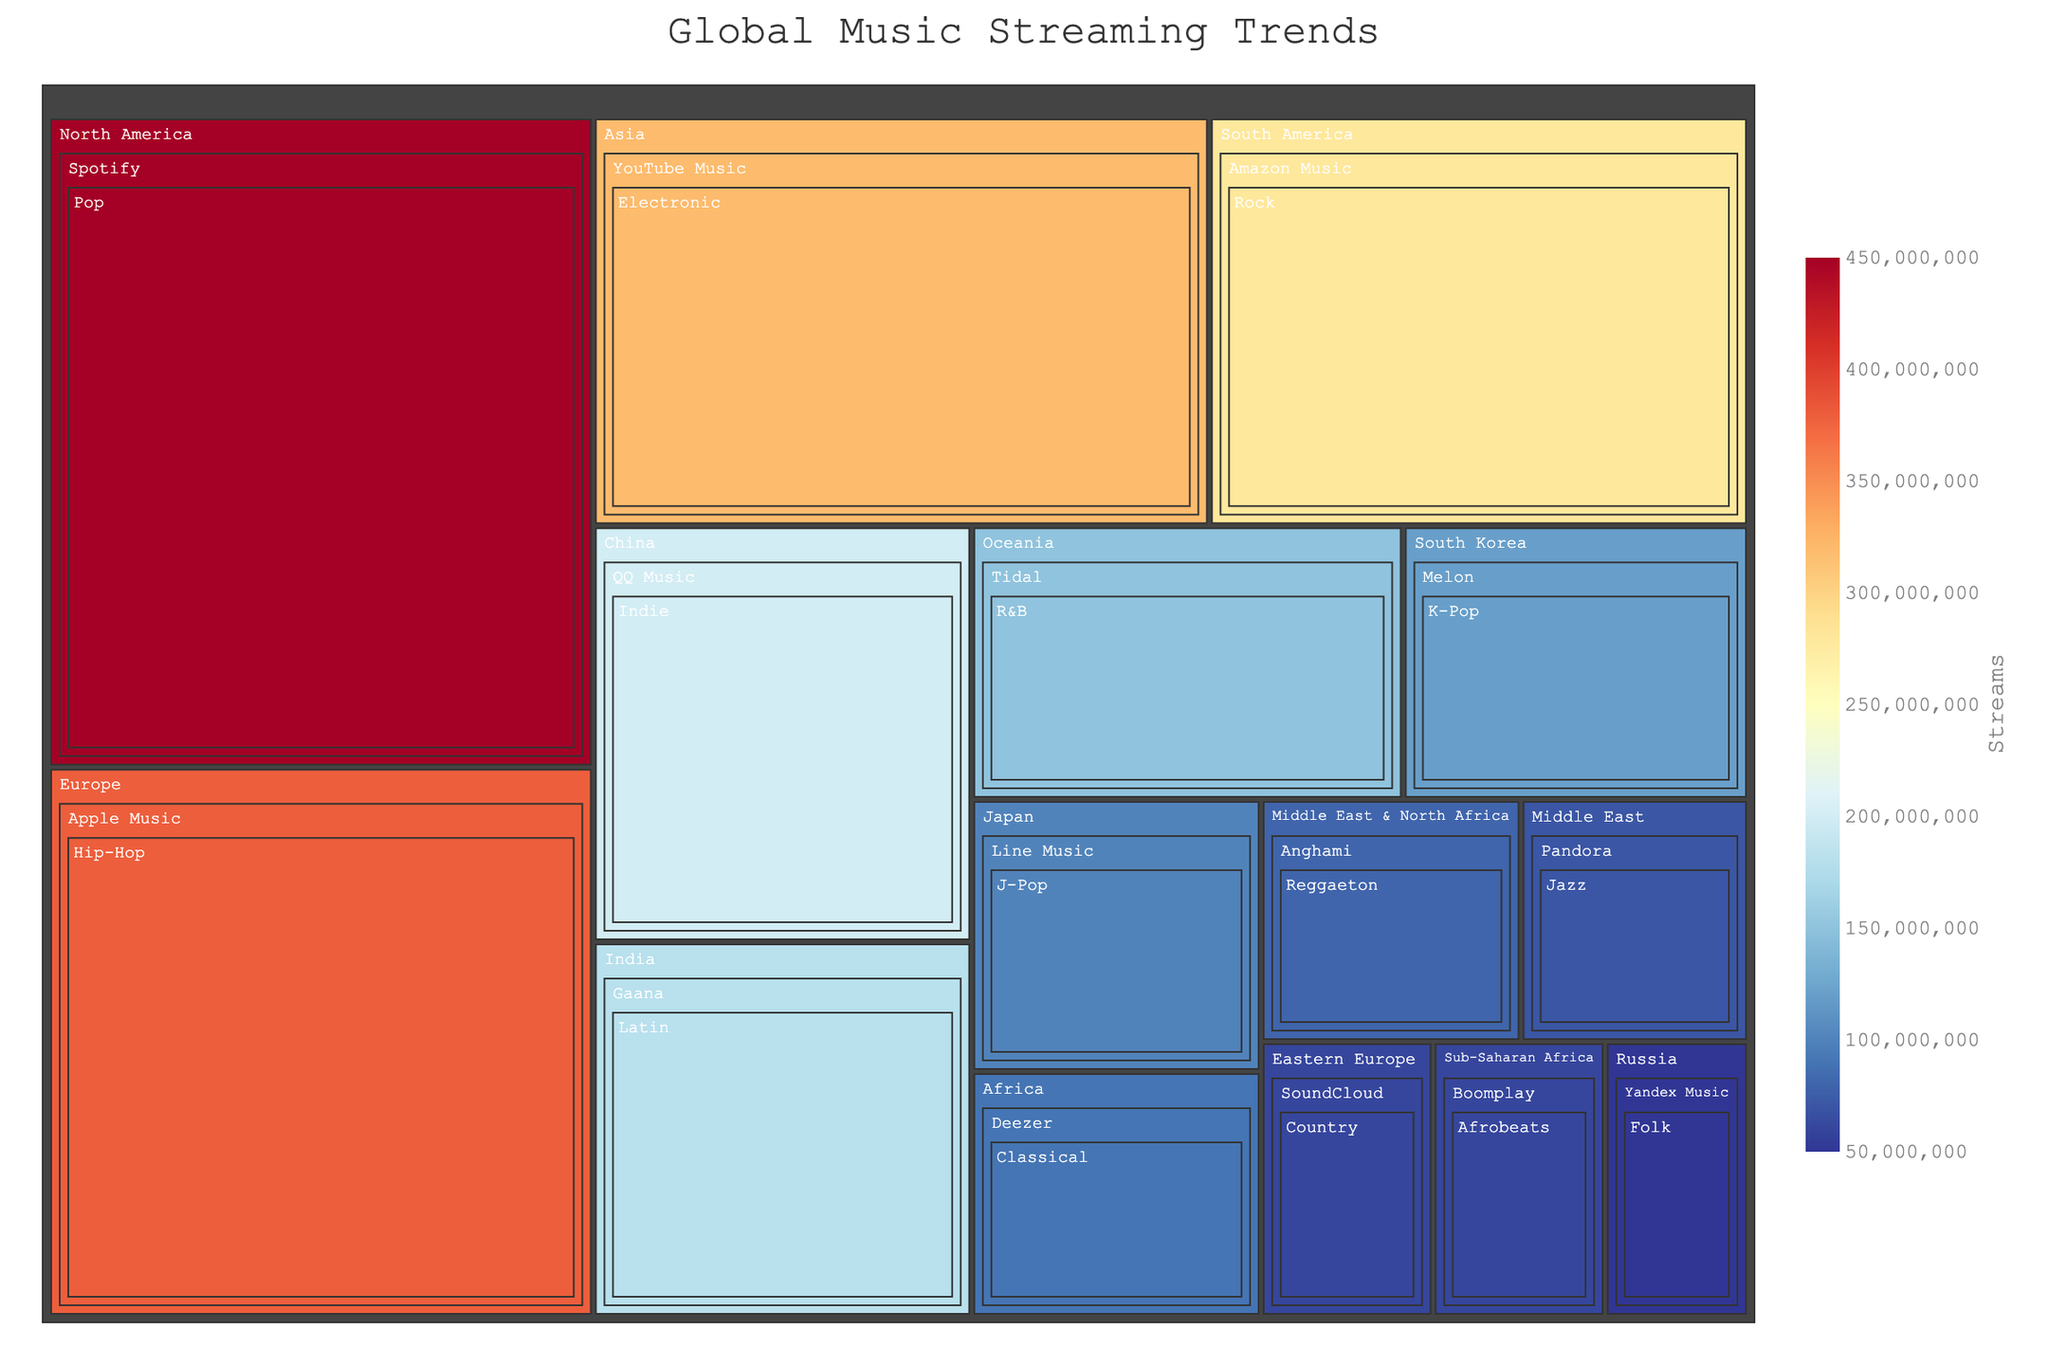How many streams does Pop music have in North America on Spotify? Locate the "North America" tile, then within it find "Spotify", and finally the "Pop" genre. The number of streams is displayed in the hover data.
Answer: 450,000,000 Which genre has the lowest number of streams globally? Search for the smallest tile in the treemap and hover over it. The smallest tile represents the genre with the lowest number of streams.
Answer: Folk How do R&B streams in Oceania on Tidal compare to Classical streams in Africa on Deezer? First, locate the "Oceania" tile, then "Tidal", and check the "R&B" streams. Next, find "Africa", then "Deezer" and check the "Classical" streams. Compare the two values.
Answer: R&B on Tidal has more streams What is the total number of streams in Asia? Identify the "Asia" tile, sum the streams from all the platforms within this region: YouTube Music (320,000,000), QQ Music (200,000,000) and Gaana (180,000,000).
Answer: 700,000,000 Which region has the most diverse platforms for music streaming? Look for the region with the most distinct platform names under its tile. The region with the most unique platforms is the most diverse.
Answer: Middle East & North Africa What is the average number of streams per platform in Europe? Locate the "Europe" tile, list all platforms, count their number: Apple Music (380,000,000). Since there is only one platform, the average is the same as the total streams.
Answer: 380,000,000 Compare the total streams of Electronic music in Asia on YouTube Music to Hip-Hop in Europe on Apple Music? Locate the "Asia" tile and find "YouTube Music" for "Electronic" streams, then check the "Europe" tile and find "Apple Music" for "Hip-Hop" streams. Then compare the two numbers.
Answer: Electronic on YouTube Music (Asia) has fewer streams In which region does Spotify have data? Identify tiles labeled with platforms within each region tile and locate where Spotify appears.
Answer: North America What is the sum of streams for all genres in the Middle East? Identify the "Middle East" tile, sum the streams for Pandora (70,000,000) and Anghami (80,000,000).
Answer: 150,000,000 